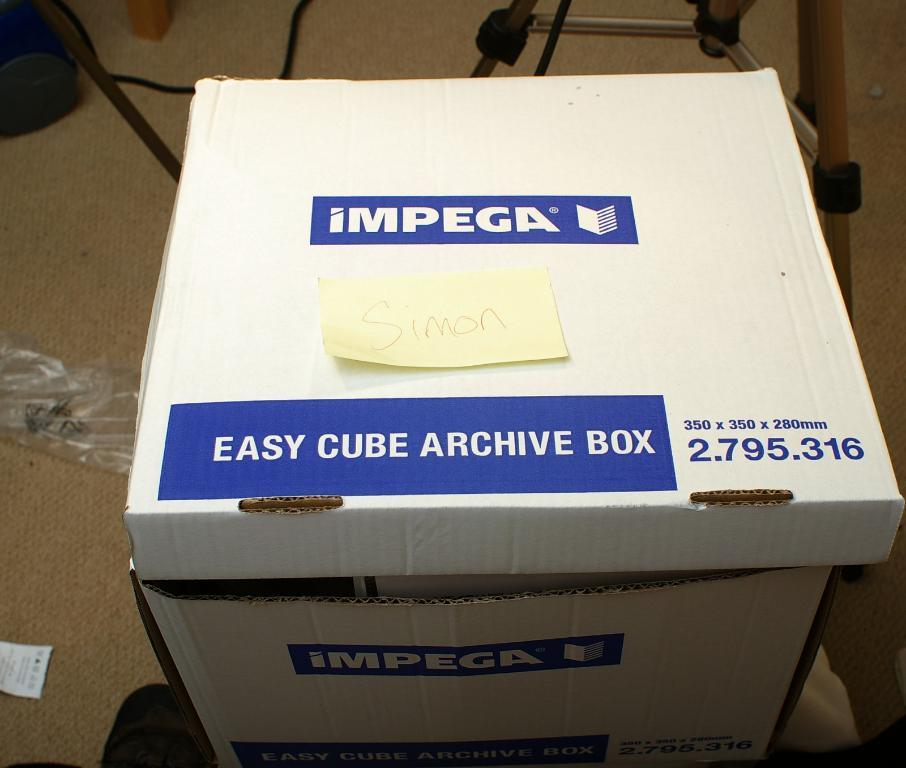<image>
Relay a brief, clear account of the picture shown. A white and blue Impega easy cube archive box. 